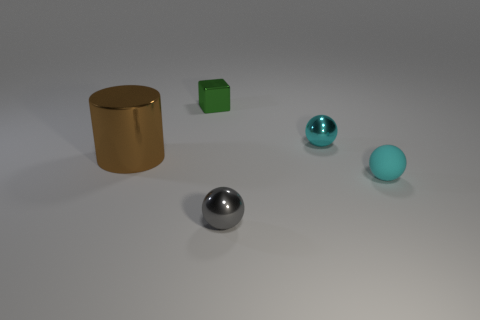There is a block that is made of the same material as the big brown cylinder; what color is it?
Your answer should be very brief. Green. There is a tiny shiny ball behind the small object in front of the matte sphere; is there a metal thing that is behind it?
Your answer should be compact. Yes. What shape is the large thing?
Keep it short and to the point. Cylinder. Is the number of big brown things behind the small cyan matte sphere less than the number of big cyan shiny cylinders?
Keep it short and to the point. No. Is there a small matte object of the same shape as the gray shiny thing?
Your answer should be compact. Yes. There is a gray thing that is the same size as the shiny block; what shape is it?
Provide a short and direct response. Sphere. What number of things are yellow metal spheres or cyan rubber spheres?
Offer a terse response. 1. Are any tiny spheres visible?
Keep it short and to the point. Yes. Are there fewer large cylinders than cyan shiny cubes?
Provide a succinct answer. No. Is there another cyan ball that has the same size as the cyan matte sphere?
Provide a succinct answer. Yes. 